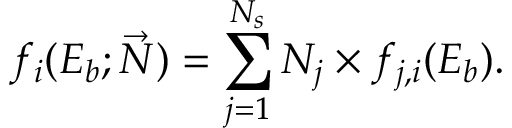<formula> <loc_0><loc_0><loc_500><loc_500>f _ { i } ( E _ { b } ; \vec { N } ) = \sum _ { j = 1 } ^ { N _ { s } } N _ { j } \times f _ { j , i } ( E _ { b } ) .</formula> 